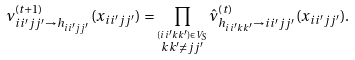<formula> <loc_0><loc_0><loc_500><loc_500>\nu _ { i i ^ { \prime } j j ^ { \prime } \to h _ { i i ^ { \prime } j j ^ { \prime } } } ^ { ( t + 1 ) } ( x _ { i i ^ { \prime } j j ^ { \prime } } ) & = \prod _ { \stackrel { ( i i ^ { \prime } k k ^ { \prime } ) \in V _ { S } } { k k ^ { \prime } \neq j j ^ { \prime } } } \hat { \nu } _ { h _ { i i ^ { \prime } k k ^ { \prime } } \to i i ^ { \prime } j j ^ { \prime } } ^ { ( t ) } ( x _ { i i ^ { \prime } j j ^ { \prime } } ) .</formula> 